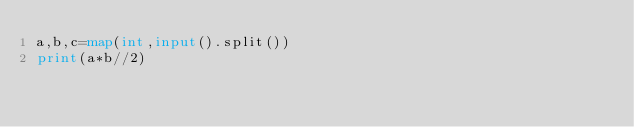Convert code to text. <code><loc_0><loc_0><loc_500><loc_500><_Python_>a,b,c=map(int,input().split())
print(a*b//2)</code> 